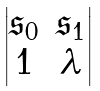Convert formula to latex. <formula><loc_0><loc_0><loc_500><loc_500>\begin{vmatrix} { \mathfrak s } _ { 0 } & { \mathfrak s } _ { 1 } \\ 1 & \lambda \\ \end{vmatrix}</formula> 